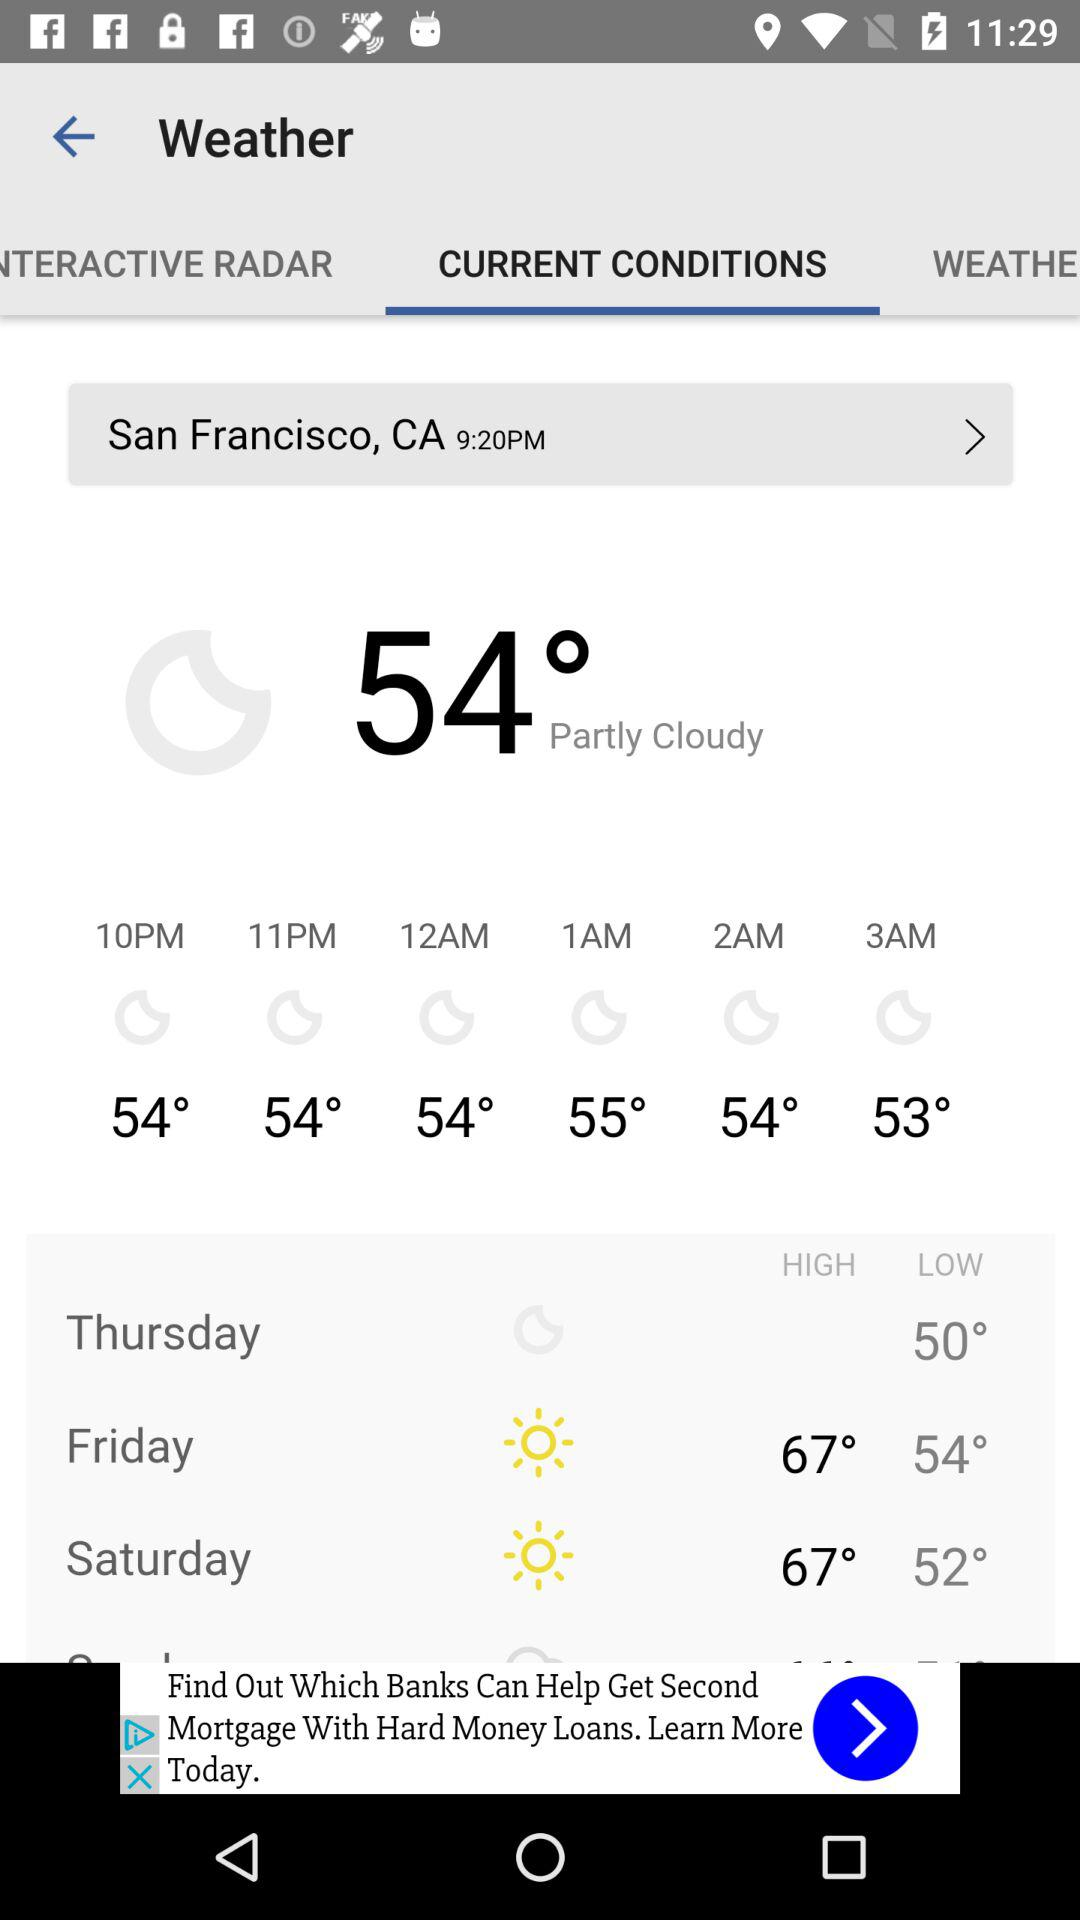How’s the weather? The weather is 54° and partly cloudy. 